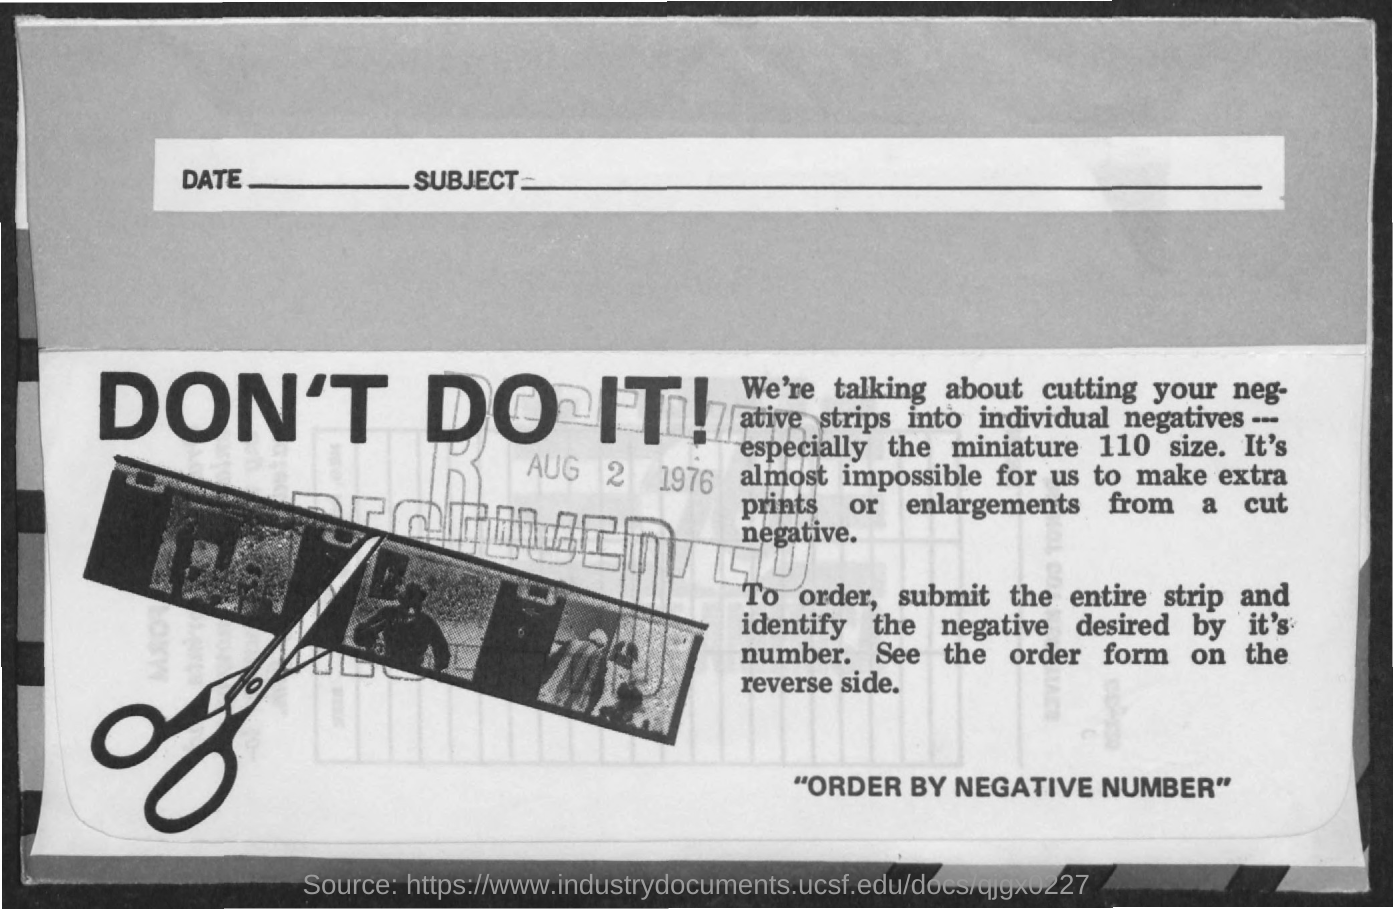Give some essential details in this illustration. The date received is August 2, 1976. 